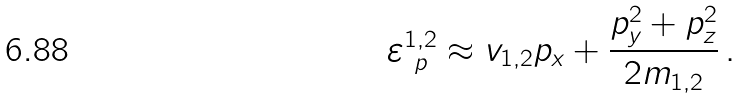Convert formula to latex. <formula><loc_0><loc_0><loc_500><loc_500>\varepsilon _ { \ p } ^ { 1 , 2 } \approx v _ { 1 , 2 } p _ { x } + \frac { p _ { y } ^ { 2 } + p _ { z } ^ { 2 } } { 2 m _ { 1 , 2 } } \, .</formula> 